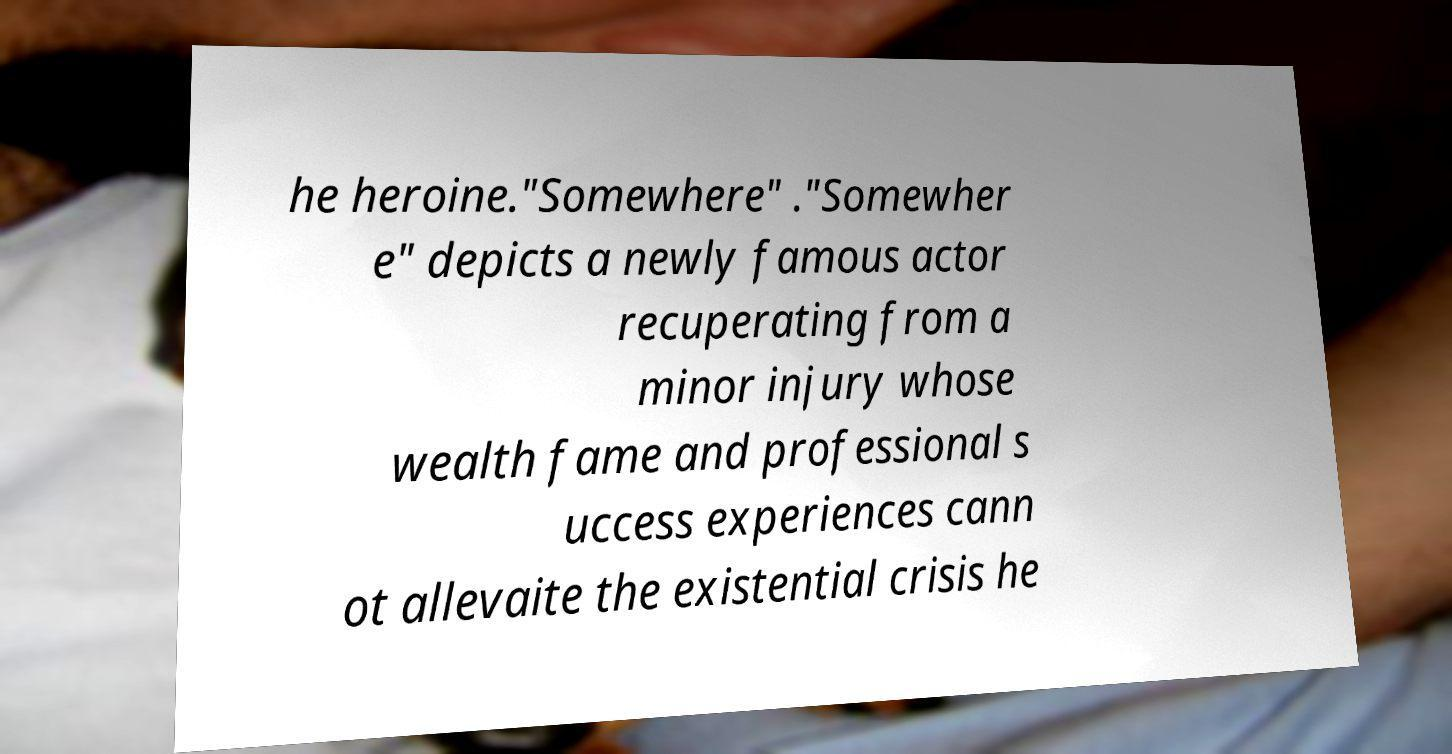Could you assist in decoding the text presented in this image and type it out clearly? he heroine."Somewhere" ."Somewher e" depicts a newly famous actor recuperating from a minor injury whose wealth fame and professional s uccess experiences cann ot allevaite the existential crisis he 